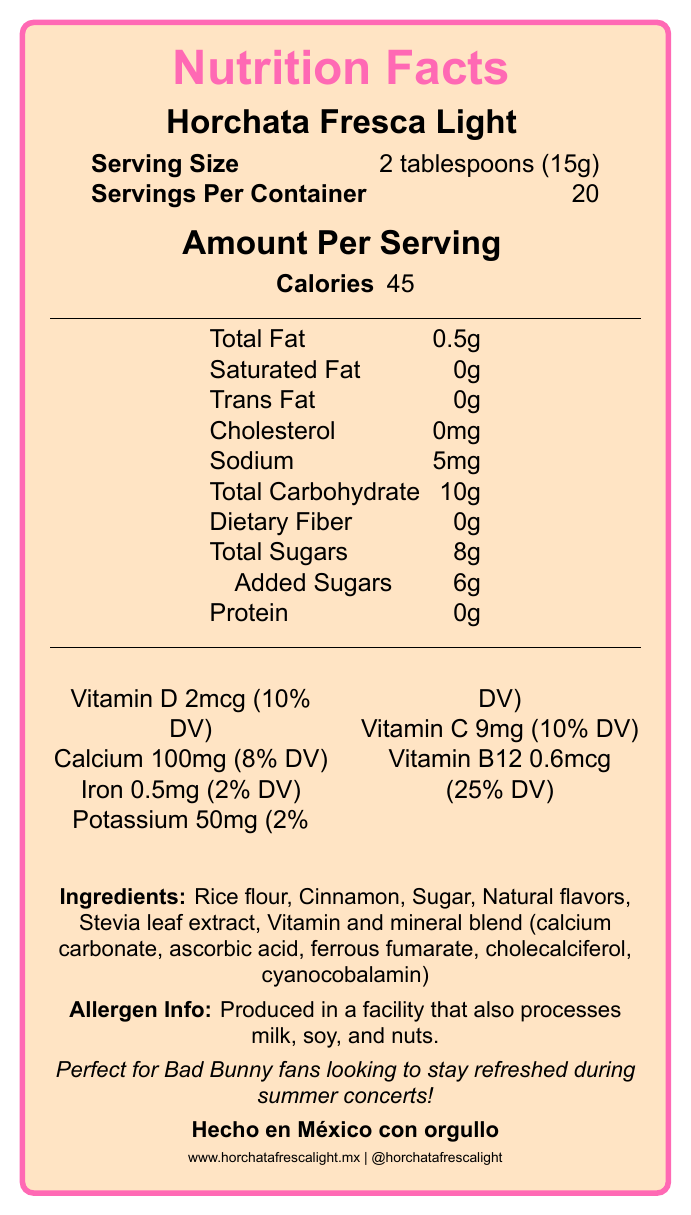what is the serving size? The serving size is listed at the top of the Nutrition Facts Label below the product name.
Answer: 2 tablespoons (15g) how many servings are in the container? The number of servings per container is provided right under the serving size information.
Answer: 20 how many calories are there per serving? The calories per serving are listed in the "Amount Per Serving" section.
Answer: 45 what are the total sugars per serving? The total amount of sugars per serving can be found in the list of nutrients.
Answer: 8g what is the amount of vitamin D per serving? The amount of vitamin D is indicated in micrograms along with its daily value percentage.
Answer: 2mcg (10% DV) what brand produces this horchata mix? The product name at the top of the label indicates the brand.
Answer: Horchata Fresca Light does this product contain any dietary fiber? The label shows that dietary fiber per serving is 0g.
Answer: No which of the following vitamins have a daily value percentage of 10%? A. Vitamin D B. Calcium C. Iron D. Vitamin C Both Vitamin D and Vitamin C have a daily value of 10% listed on the label.
Answer: A and D what is the sodium content per serving? A. 5mg B. 10mg C. 50mg D. 100mg The sodium content per serving is listed as 5mg.
Answer: A are there any proteins per serving? The label lists 0g of protein per serving.
Answer: No is this product suitable for vegans? The label shows that it is certified Vegan.
Answer: Yes what allergens might be present in the production of this product? The allergen information states that the product is produced in a facility that also processes milk, soy, and nuts.
Answer: Milk, soy, nuts how is the product recommended to be stored after opening? The storage instructions provide these specific recommendations.
Answer: Store in a cool, dry place. After opening, reseal package tightly and consume within 3 months. summarize the main idea of this Nutrition Facts Label. The summary includes all major aspects of the Nutrition Facts Label including product highlights and instructions.
Answer: The document is a detailed Nutrition Facts Label for "Horchata Fresca Light," a low-calorie horchata mix enriched with vitamins and minerals. It contains nutrition information, ingredient list, allergen information, preparation instructions, and storage guidelines. It emphasizes being a lighter, healthier option suitable for Bad Bunny fans. what is the phone number for contact information? The phone number is listed in the contact information section.
Answer: +52 (55) 1234-5678 where is this product made? It is stated in the document that the product is "Hecho en México con orgullo."
Answer: Hecho en México how much calcium is in one serving? The label specifies that each serving contains 100mg of calcium, which accounts for 8% of the daily value.
Answer: 100mg (8% DV) is there any information about the environmental or ethical certifications of this product? The label indicates certifications such as "Non-GMO Project Verified," "Vegan," and "Gluten-Free."
Answer: Yes how many grams of rice flour are there per serving? The document does not provide specific quantities of individual ingredients per serving, just the total amount of the mix per serving.
Answer: Not enough information according to the label, what is a fun suggestion for an extra kick when preparing the drink? The preparation instructions include a suggestion for adding a splash of rum.
Answer: Add a splash of rum 